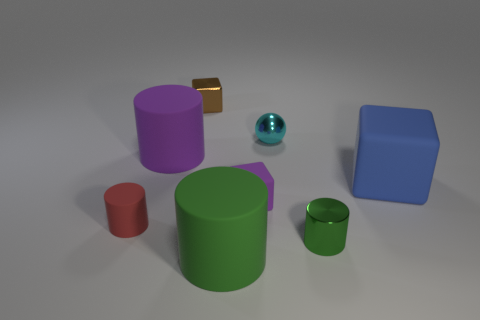Are there any other blue matte objects that have the same shape as the big blue matte thing?
Offer a very short reply. No. What is the color of the other metallic block that is the same size as the purple cube?
Your answer should be compact. Brown. There is a small cylinder in front of the tiny cylinder on the left side of the green rubber object; what color is it?
Make the answer very short. Green. Do the metal thing in front of the blue rubber cube and the metal sphere have the same color?
Offer a very short reply. No. There is a large thing to the right of the large matte cylinder in front of the tiny cylinder that is to the left of the small cyan sphere; what shape is it?
Offer a terse response. Cube. How many green metallic objects are behind the block behind the large purple cylinder?
Provide a succinct answer. 0. Is the ball made of the same material as the tiny red object?
Keep it short and to the point. No. There is a matte cylinder that is on the right side of the tiny metal thing that is behind the cyan metallic ball; how many blue cubes are to the left of it?
Your answer should be compact. 0. There is a cylinder behind the blue rubber cube; what is its color?
Keep it short and to the point. Purple. There is a metal object that is left of the rubber object in front of the tiny green thing; what shape is it?
Give a very brief answer. Cube. 